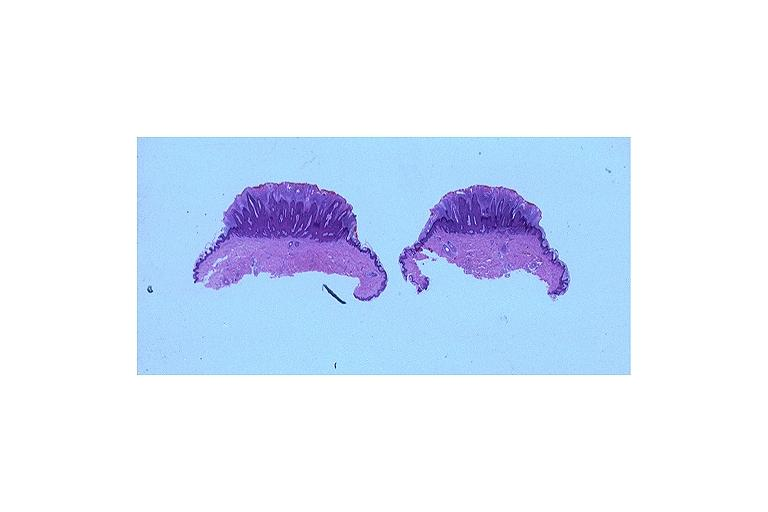where is this?
Answer the question using a single word or phrase. Oral 